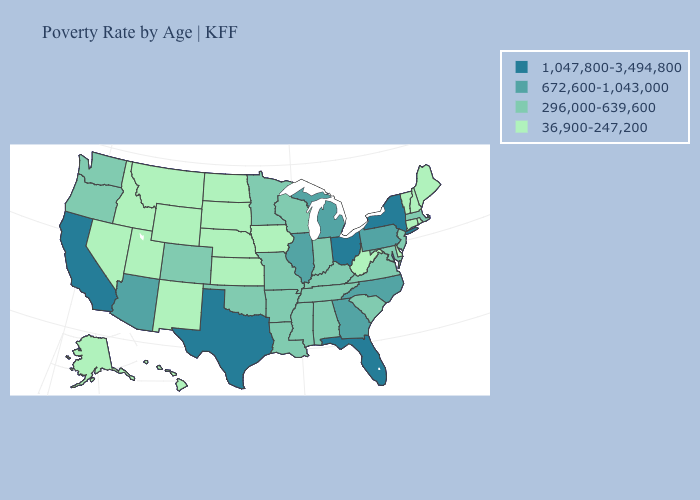How many symbols are there in the legend?
Write a very short answer. 4. What is the value of Rhode Island?
Answer briefly. 36,900-247,200. Name the states that have a value in the range 672,600-1,043,000?
Quick response, please. Arizona, Georgia, Illinois, Michigan, North Carolina, Pennsylvania. Among the states that border Virginia , which have the highest value?
Give a very brief answer. North Carolina. Among the states that border Pennsylvania , does New Jersey have the lowest value?
Answer briefly. No. What is the value of Nebraska?
Keep it brief. 36,900-247,200. Name the states that have a value in the range 296,000-639,600?
Write a very short answer. Alabama, Arkansas, Colorado, Indiana, Kentucky, Louisiana, Maryland, Massachusetts, Minnesota, Mississippi, Missouri, New Jersey, Oklahoma, Oregon, South Carolina, Tennessee, Virginia, Washington, Wisconsin. Among the states that border South Dakota , does Montana have the lowest value?
Keep it brief. Yes. Does the first symbol in the legend represent the smallest category?
Answer briefly. No. Does Alaska have the highest value in the USA?
Short answer required. No. Does Florida have the highest value in the South?
Give a very brief answer. Yes. Among the states that border Florida , does Georgia have the lowest value?
Be succinct. No. Name the states that have a value in the range 1,047,800-3,494,800?
Quick response, please. California, Florida, New York, Ohio, Texas. Does Mississippi have a higher value than Kansas?
Keep it brief. Yes. 